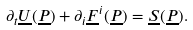<formula> <loc_0><loc_0><loc_500><loc_500>\partial _ { t } \underline { U } ( \underline { P } ) + \partial _ { i } \underline { F } ^ { i } ( \underline { P } ) = \underline { S } ( \underline { P } ) .</formula> 